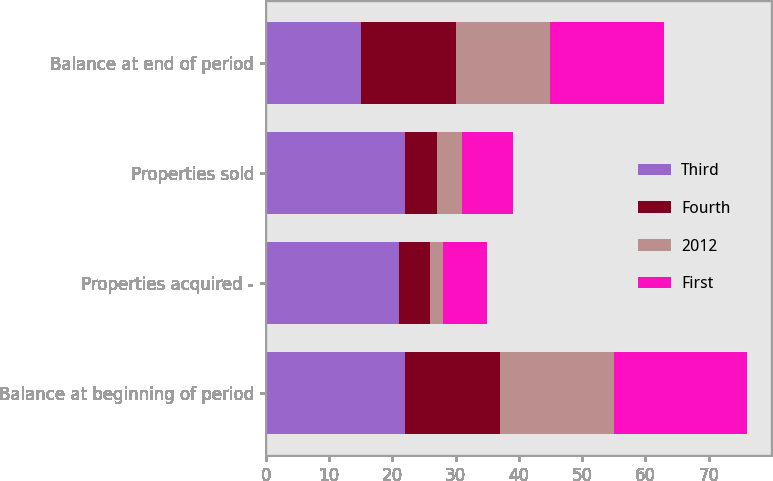<chart> <loc_0><loc_0><loc_500><loc_500><stacked_bar_chart><ecel><fcel>Balance at beginning of period<fcel>Properties acquired -<fcel>Properties sold<fcel>Balance at end of period<nl><fcel>Third<fcel>22<fcel>21<fcel>22<fcel>15<nl><fcel>Fourth<fcel>15<fcel>5<fcel>5<fcel>15<nl><fcel>2012<fcel>18<fcel>2<fcel>4<fcel>15<nl><fcel>First<fcel>21<fcel>7<fcel>8<fcel>18<nl></chart> 